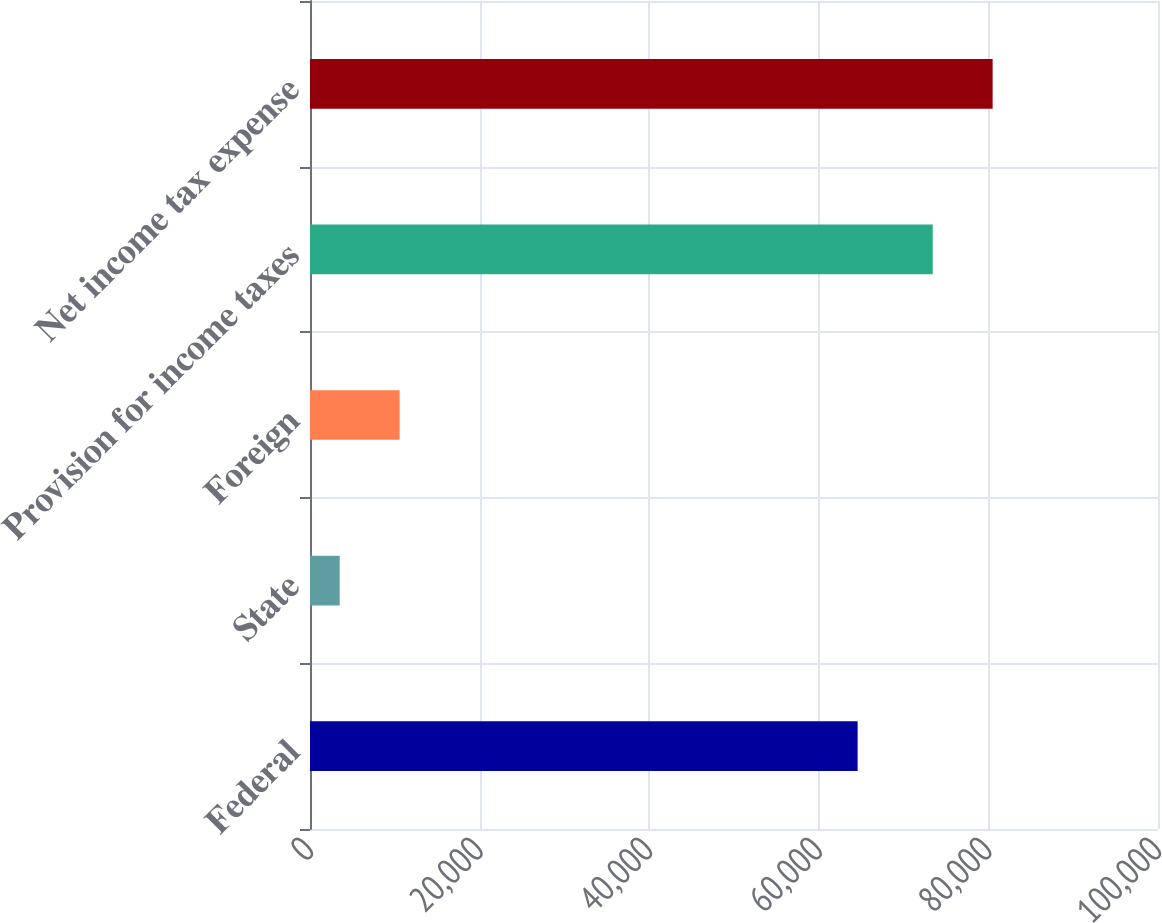Convert chart. <chart><loc_0><loc_0><loc_500><loc_500><bar_chart><fcel>Federal<fcel>State<fcel>Foreign<fcel>Provision for income taxes<fcel>Net income tax expense<nl><fcel>64579<fcel>3501<fcel>10564.1<fcel>73436<fcel>80499.1<nl></chart> 